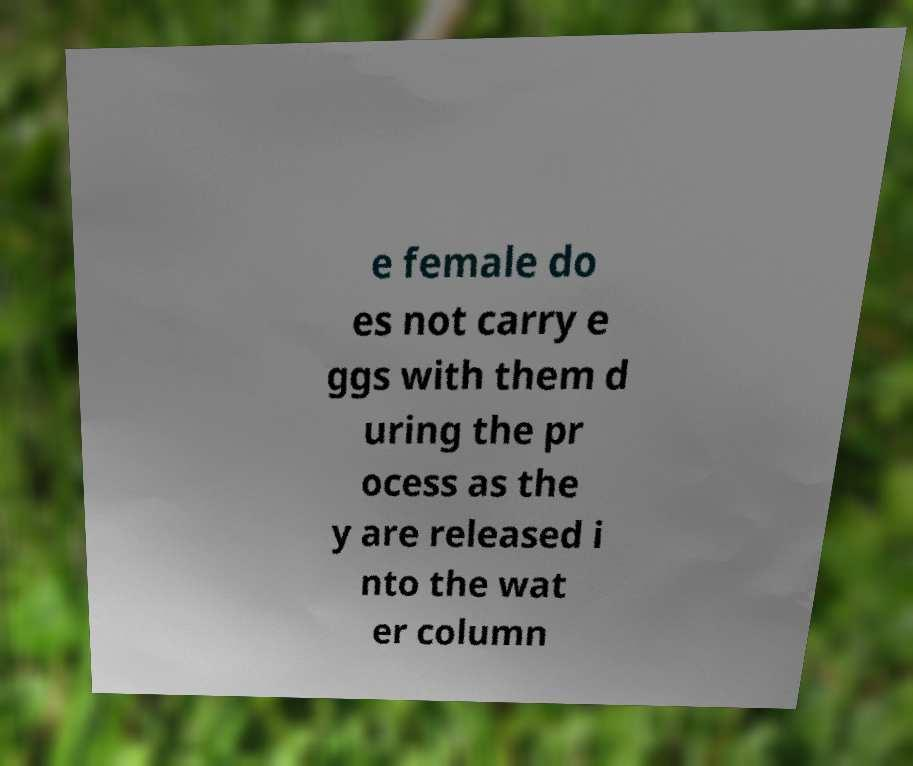What messages or text are displayed in this image? I need them in a readable, typed format. e female do es not carry e ggs with them d uring the pr ocess as the y are released i nto the wat er column 